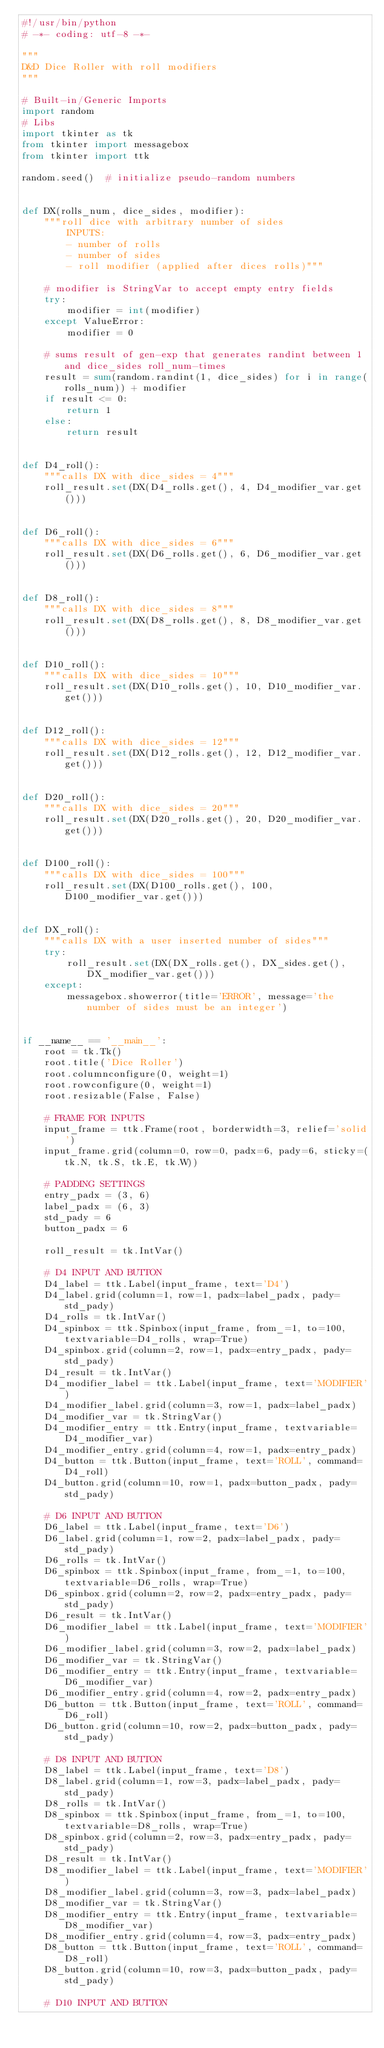<code> <loc_0><loc_0><loc_500><loc_500><_Python_>#!/usr/bin/python
# -*- coding: utf-8 -*-

"""
D&D Dice Roller with roll modifiers
"""

# Built-in/Generic Imports
import random
# Libs
import tkinter as tk
from tkinter import messagebox
from tkinter import ttk

random.seed()  # initialize pseudo-random numbers


def DX(rolls_num, dice_sides, modifier):
    """roll dice with arbitrary number of sides
        INPUTS:
        - number of rolls
        - number of sides
        - roll modifier (applied after dices rolls)"""

    # modifier is StringVar to accept empty entry fields
    try:
        modifier = int(modifier)
    except ValueError:
        modifier = 0

    # sums result of gen-exp that generates randint between 1 and dice_sides roll_num-times
    result = sum(random.randint(1, dice_sides) for i in range(rolls_num)) + modifier
    if result <= 0:
        return 1
    else:
        return result


def D4_roll():
    """calls DX with dice_sides = 4"""
    roll_result.set(DX(D4_rolls.get(), 4, D4_modifier_var.get()))


def D6_roll():
    """calls DX with dice_sides = 6"""
    roll_result.set(DX(D6_rolls.get(), 6, D6_modifier_var.get()))


def D8_roll():
    """calls DX with dice_sides = 8"""
    roll_result.set(DX(D8_rolls.get(), 8, D8_modifier_var.get()))


def D10_roll():
    """calls DX with dice_sides = 10"""
    roll_result.set(DX(D10_rolls.get(), 10, D10_modifier_var.get()))


def D12_roll():
    """calls DX with dice_sides = 12"""
    roll_result.set(DX(D12_rolls.get(), 12, D12_modifier_var.get()))


def D20_roll():
    """calls DX with dice_sides = 20"""
    roll_result.set(DX(D20_rolls.get(), 20, D20_modifier_var.get()))


def D100_roll():
    """calls DX with dice_sides = 100"""
    roll_result.set(DX(D100_rolls.get(), 100, D100_modifier_var.get()))


def DX_roll():
    """calls DX with a user inserted number of sides"""
    try:
        roll_result.set(DX(DX_rolls.get(), DX_sides.get(), DX_modifier_var.get()))
    except:
        messagebox.showerror(title='ERROR', message='the number of sides must be an integer')


if __name__ == '__main__':
    root = tk.Tk()
    root.title('Dice Roller')
    root.columnconfigure(0, weight=1)
    root.rowconfigure(0, weight=1)
    root.resizable(False, False)

    # FRAME FOR INPUTS
    input_frame = ttk.Frame(root, borderwidth=3, relief='solid')
    input_frame.grid(column=0, row=0, padx=6, pady=6, sticky=(tk.N, tk.S, tk.E, tk.W))

    # PADDING SETTINGS
    entry_padx = (3, 6)
    label_padx = (6, 3)
    std_pady = 6
    button_padx = 6

    roll_result = tk.IntVar()

    # D4 INPUT AND BUTTON
    D4_label = ttk.Label(input_frame, text='D4')
    D4_label.grid(column=1, row=1, padx=label_padx, pady=std_pady)
    D4_rolls = tk.IntVar()
    D4_spinbox = ttk.Spinbox(input_frame, from_=1, to=100, textvariable=D4_rolls, wrap=True)
    D4_spinbox.grid(column=2, row=1, padx=entry_padx, pady=std_pady)
    D4_result = tk.IntVar()
    D4_modifier_label = ttk.Label(input_frame, text='MODIFIER')
    D4_modifier_label.grid(column=3, row=1, padx=label_padx)
    D4_modifier_var = tk.StringVar()
    D4_modifier_entry = ttk.Entry(input_frame, textvariable=D4_modifier_var)
    D4_modifier_entry.grid(column=4, row=1, padx=entry_padx)
    D4_button = ttk.Button(input_frame, text='ROLL', command=D4_roll)
    D4_button.grid(column=10, row=1, padx=button_padx, pady=std_pady)

    # D6 INPUT AND BUTTON
    D6_label = ttk.Label(input_frame, text='D6')
    D6_label.grid(column=1, row=2, padx=label_padx, pady=std_pady)
    D6_rolls = tk.IntVar()
    D6_spinbox = ttk.Spinbox(input_frame, from_=1, to=100, textvariable=D6_rolls, wrap=True)
    D6_spinbox.grid(column=2, row=2, padx=entry_padx, pady=std_pady)
    D6_result = tk.IntVar()
    D6_modifier_label = ttk.Label(input_frame, text='MODIFIER')
    D6_modifier_label.grid(column=3, row=2, padx=label_padx)
    D6_modifier_var = tk.StringVar()
    D6_modifier_entry = ttk.Entry(input_frame, textvariable=D6_modifier_var)
    D6_modifier_entry.grid(column=4, row=2, padx=entry_padx)
    D6_button = ttk.Button(input_frame, text='ROLL', command=D6_roll)
    D6_button.grid(column=10, row=2, padx=button_padx, pady=std_pady)

    # D8 INPUT AND BUTTON
    D8_label = ttk.Label(input_frame, text='D8')
    D8_label.grid(column=1, row=3, padx=label_padx, pady=std_pady)
    D8_rolls = tk.IntVar()
    D8_spinbox = ttk.Spinbox(input_frame, from_=1, to=100, textvariable=D8_rolls, wrap=True)
    D8_spinbox.grid(column=2, row=3, padx=entry_padx, pady=std_pady)
    D8_result = tk.IntVar()
    D8_modifier_label = ttk.Label(input_frame, text='MODIFIER')
    D8_modifier_label.grid(column=3, row=3, padx=label_padx)
    D8_modifier_var = tk.StringVar()
    D8_modifier_entry = ttk.Entry(input_frame, textvariable=D8_modifier_var)
    D8_modifier_entry.grid(column=4, row=3, padx=entry_padx)
    D8_button = ttk.Button(input_frame, text='ROLL', command=D8_roll)
    D8_button.grid(column=10, row=3, padx=button_padx, pady=std_pady)

    # D10 INPUT AND BUTTON</code> 